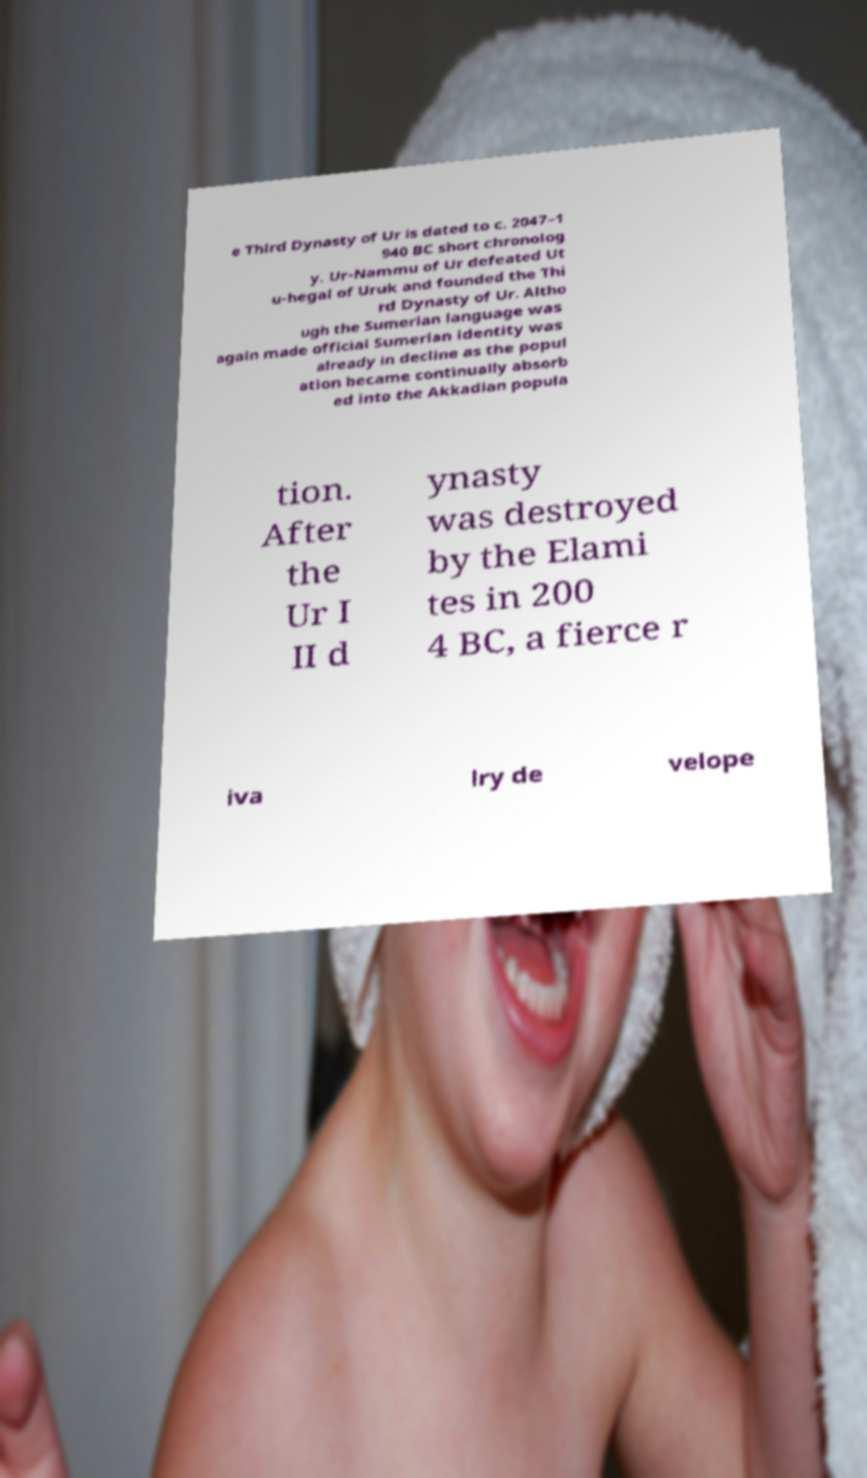Please read and relay the text visible in this image. What does it say? e Third Dynasty of Ur is dated to c. 2047–1 940 BC short chronolog y. Ur-Nammu of Ur defeated Ut u-hegal of Uruk and founded the Thi rd Dynasty of Ur. Altho ugh the Sumerian language was again made official Sumerian identity was already in decline as the popul ation became continually absorb ed into the Akkadian popula tion. After the Ur I II d ynasty was destroyed by the Elami tes in 200 4 BC, a fierce r iva lry de velope 